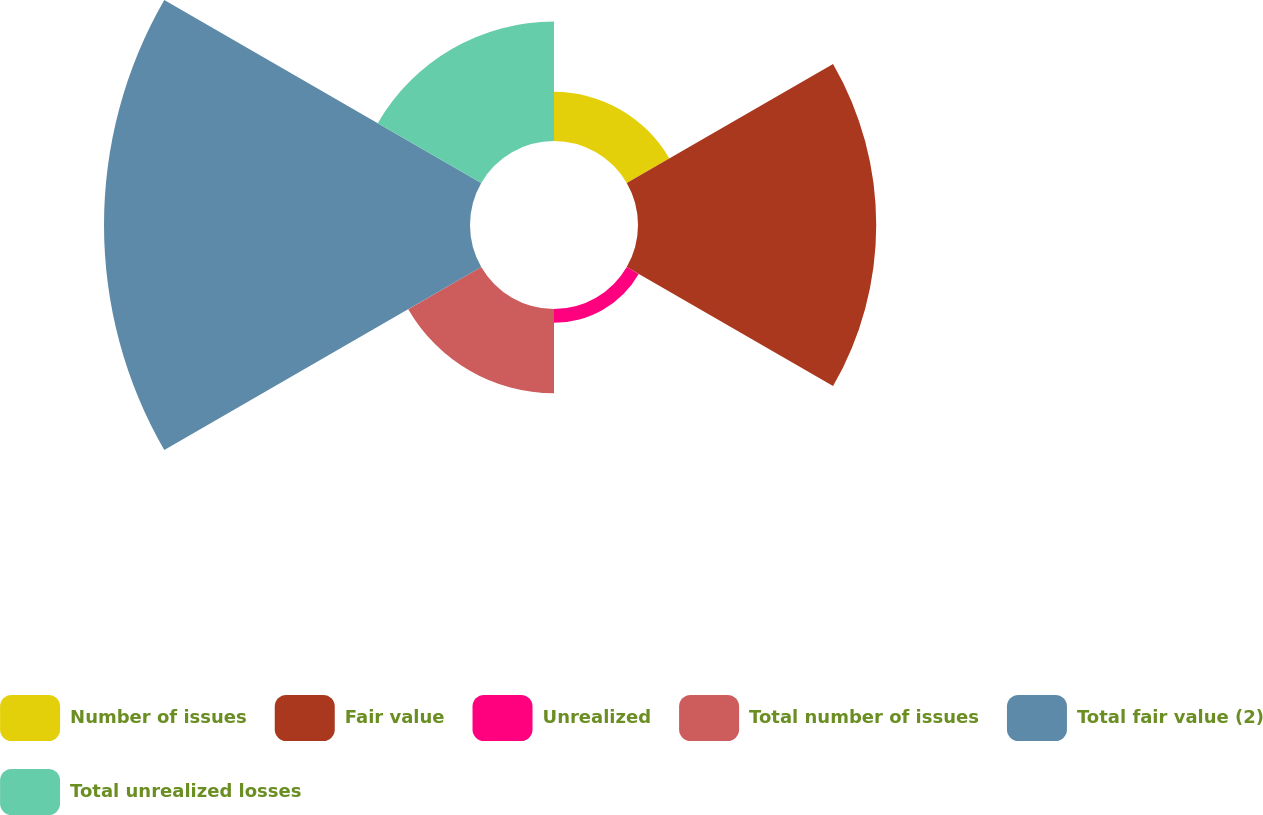Convert chart. <chart><loc_0><loc_0><loc_500><loc_500><pie_chart><fcel>Number of issues<fcel>Fair value<fcel>Unrealized<fcel>Total number of issues<fcel>Total fair value (2)<fcel>Total unrealized losses<nl><fcel>5.64%<fcel>27.35%<fcel>1.59%<fcel>9.68%<fcel>42.02%<fcel>13.72%<nl></chart> 